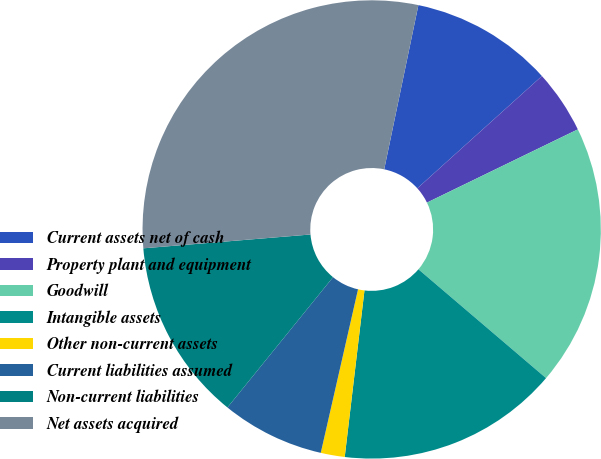Convert chart to OTSL. <chart><loc_0><loc_0><loc_500><loc_500><pie_chart><fcel>Current assets net of cash<fcel>Property plant and equipment<fcel>Goodwill<fcel>Intangible assets<fcel>Other non-current assets<fcel>Current liabilities assumed<fcel>Non-current liabilities<fcel>Net assets acquired<nl><fcel>10.06%<fcel>4.48%<fcel>18.43%<fcel>15.64%<fcel>1.69%<fcel>7.27%<fcel>12.85%<fcel>29.58%<nl></chart> 